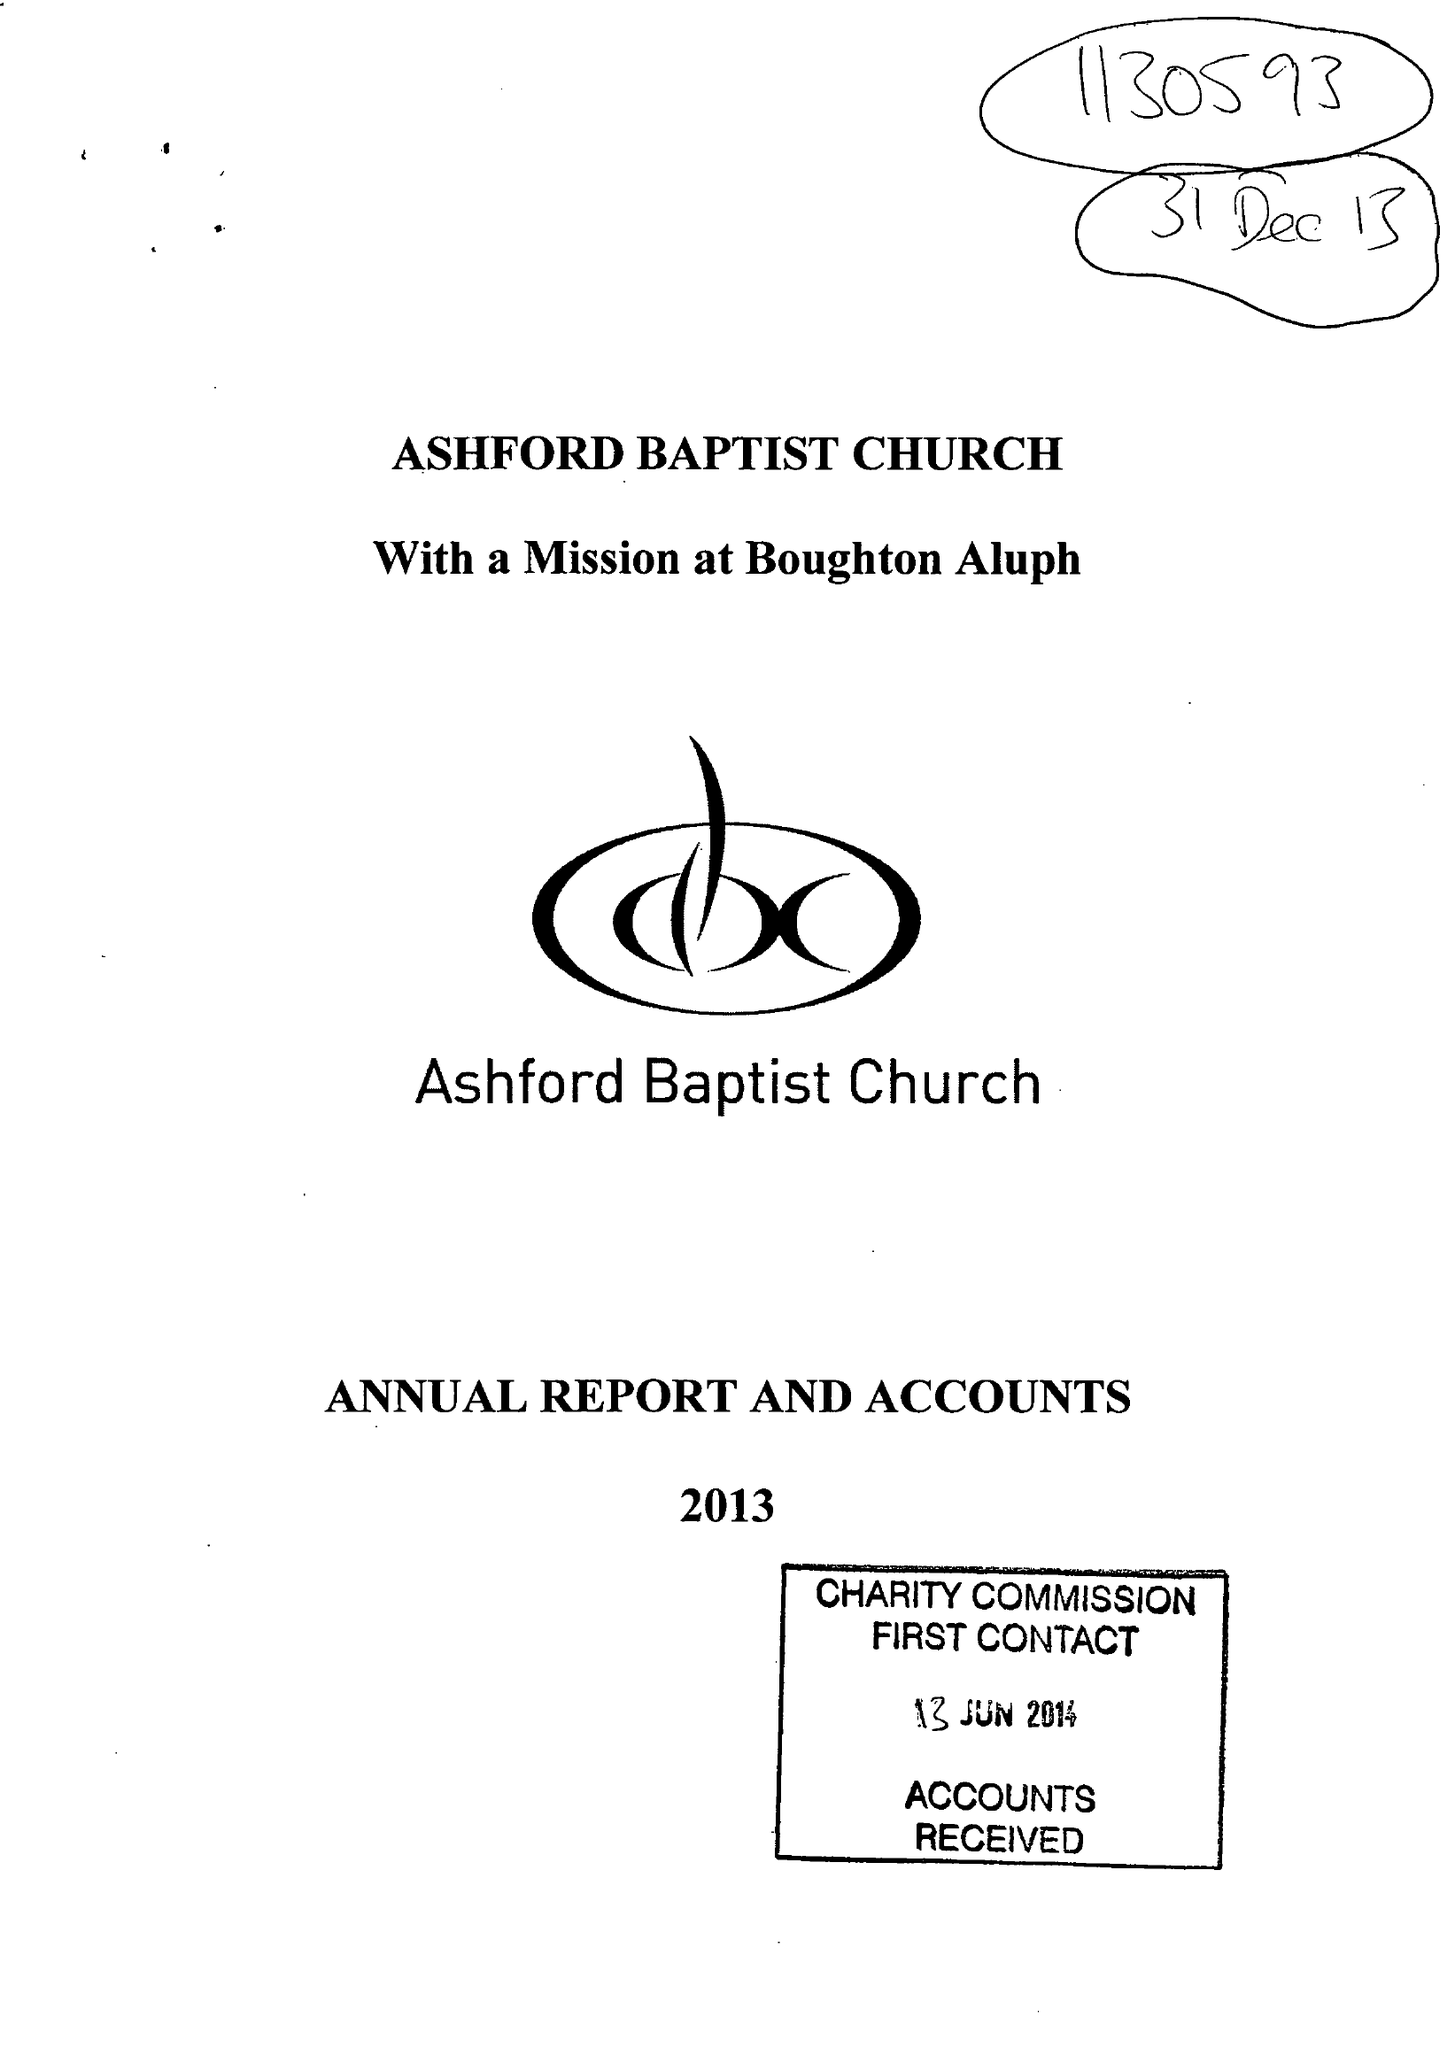What is the value for the address__street_line?
Answer the question using a single word or phrase. ST. JOHNS LANE 